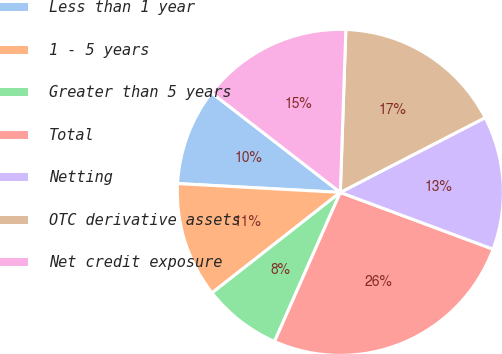<chart> <loc_0><loc_0><loc_500><loc_500><pie_chart><fcel>Less than 1 year<fcel>1 - 5 years<fcel>Greater than 5 years<fcel>Total<fcel>Netting<fcel>OTC derivative assets<fcel>Net credit exposure<nl><fcel>9.62%<fcel>11.44%<fcel>7.81%<fcel>25.95%<fcel>13.25%<fcel>16.88%<fcel>15.06%<nl></chart> 